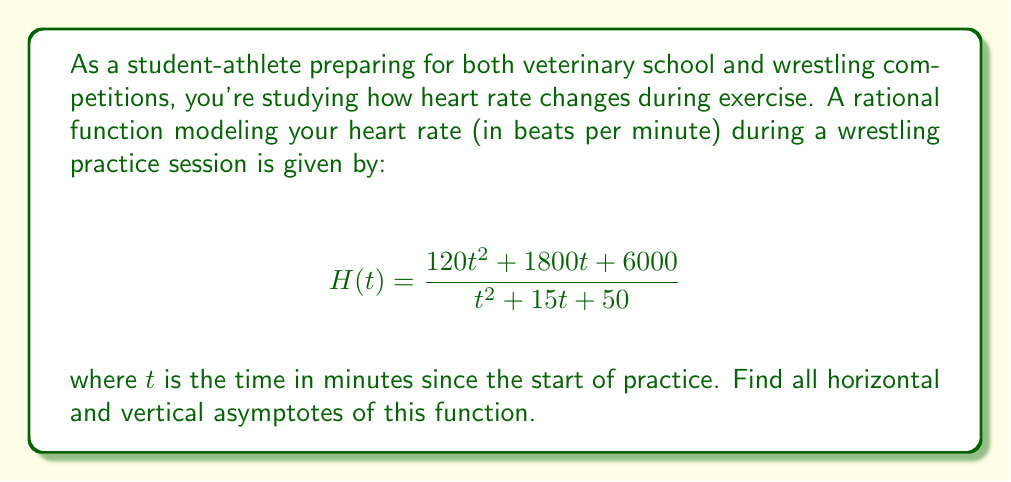What is the answer to this math problem? To find the asymptotes of this rational function, we'll follow these steps:

1) Vertical asymptotes:
   Vertical asymptotes occur when the denominator equals zero. Let's solve:
   $$t^2 + 15t + 50 = 0$$
   Using the quadratic formula: $t = \frac{-b \pm \sqrt{b^2 - 4ac}}{2a}$
   $$t = \frac{-15 \pm \sqrt{15^2 - 4(1)(50)}}{2(1)} = \frac{-15 \pm \sqrt{25}}{2} = \frac{-15 \pm 5}{2}$$
   This gives us $t = -10$ or $t = -5$. However, since time cannot be negative in this context, there are no vertical asymptotes in the domain of interest.

2) Horizontal asymptote:
   To find the horizontal asymptote, we compare the degrees of the numerator and denominator:
   - Degree of numerator: 2
   - Degree of denominator: 2
   
   When these are equal, the horizontal asymptote is the ratio of the leading coefficients:
   $$\lim_{t \to \infty} H(t) = \frac{120}{1} = 120$$

Therefore, the horizontal asymptote is $y = 120$.

This makes sense in the context of heart rate during exercise, as it suggests your heart rate approaches but doesn't exceed 120 bpm during an extended practice session.
Answer: Horizontal asymptote: $y = 120$; No vertical asymptotes in the domain of interest. 